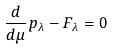Convert formula to latex. <formula><loc_0><loc_0><loc_500><loc_500>\frac { d } { d \mu } p _ { \lambda } - F _ { \lambda } = 0</formula> 